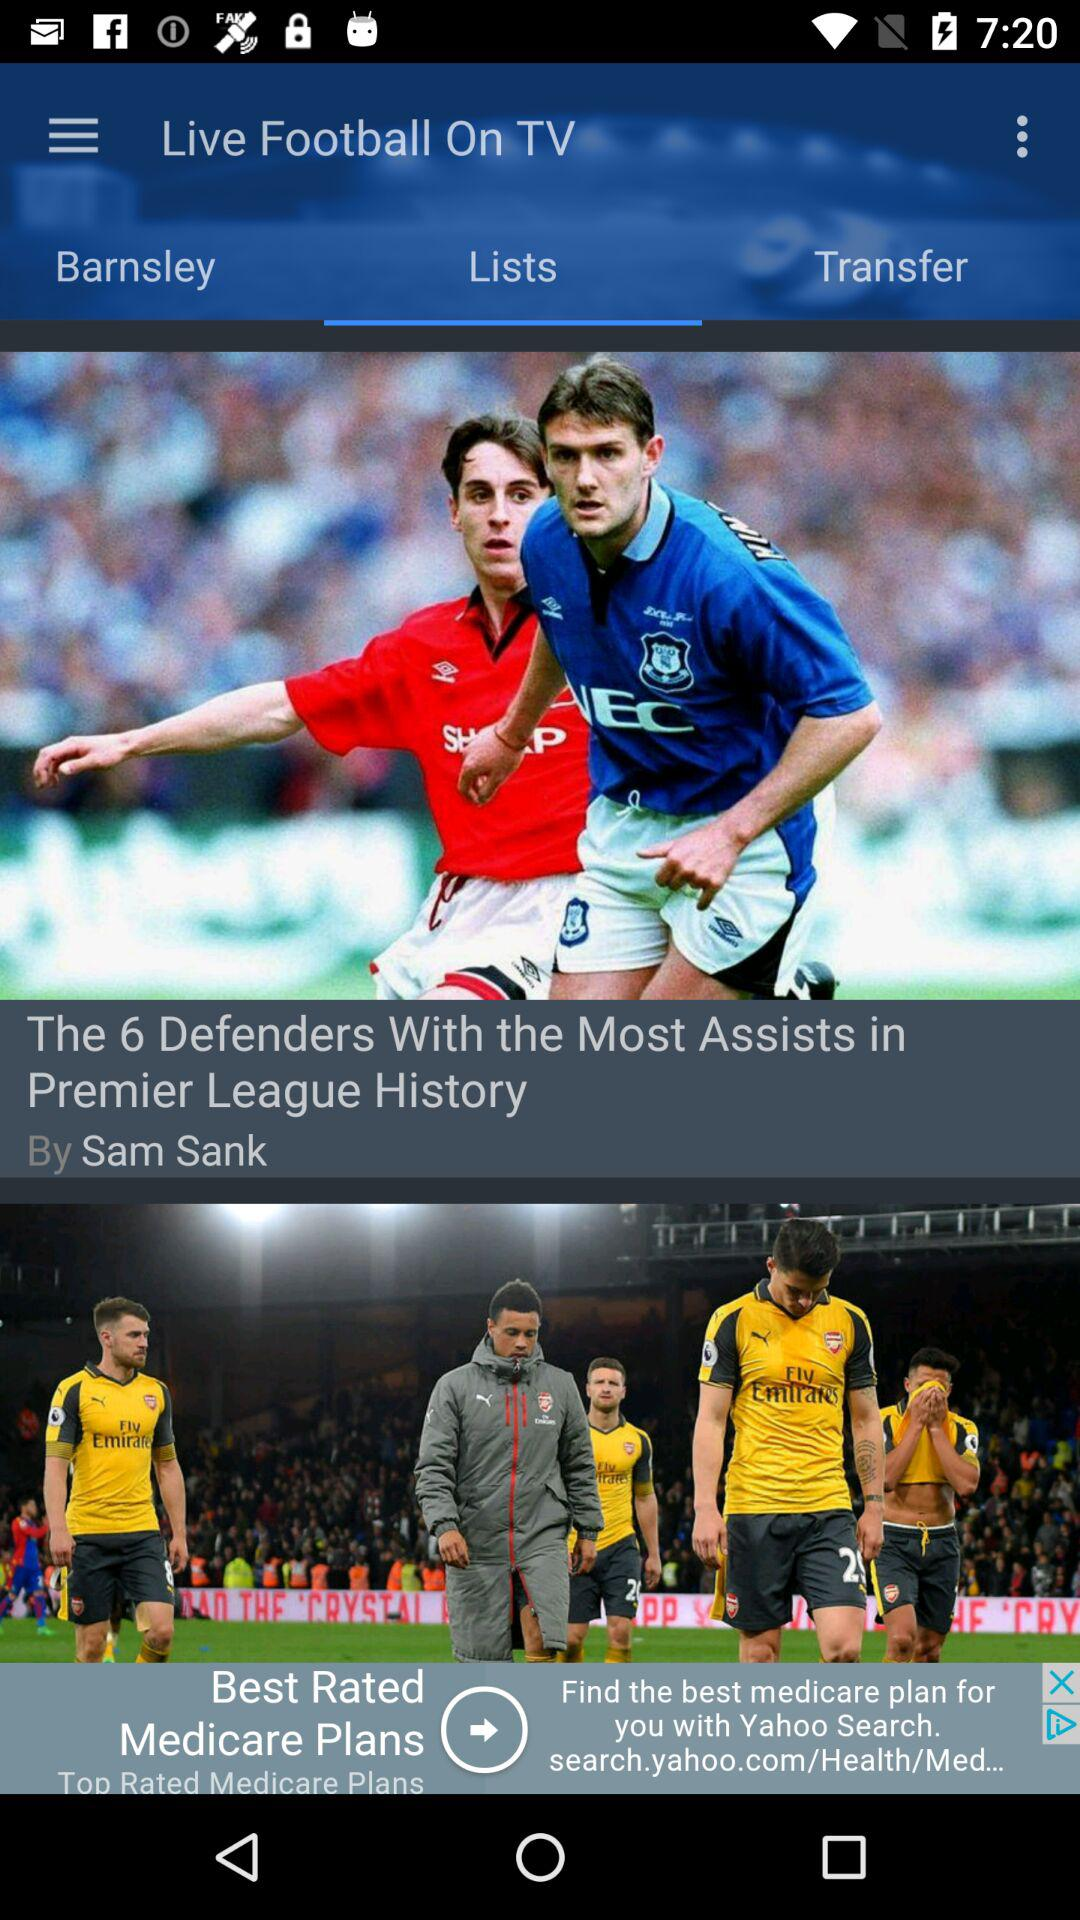Who is the author of the article? The author of the article is Sam Sank. 